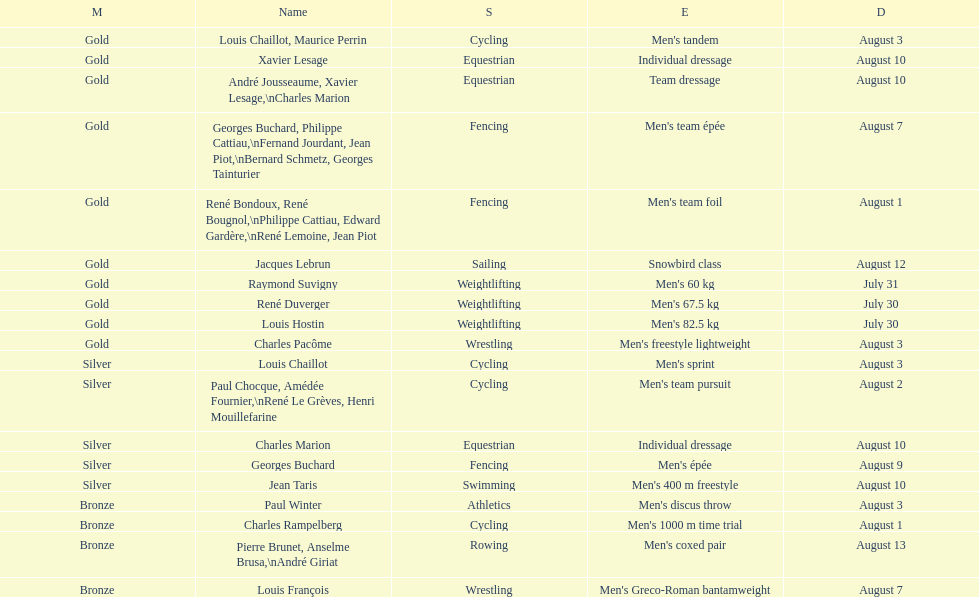What is next date that is listed after august 7th? August 1. 